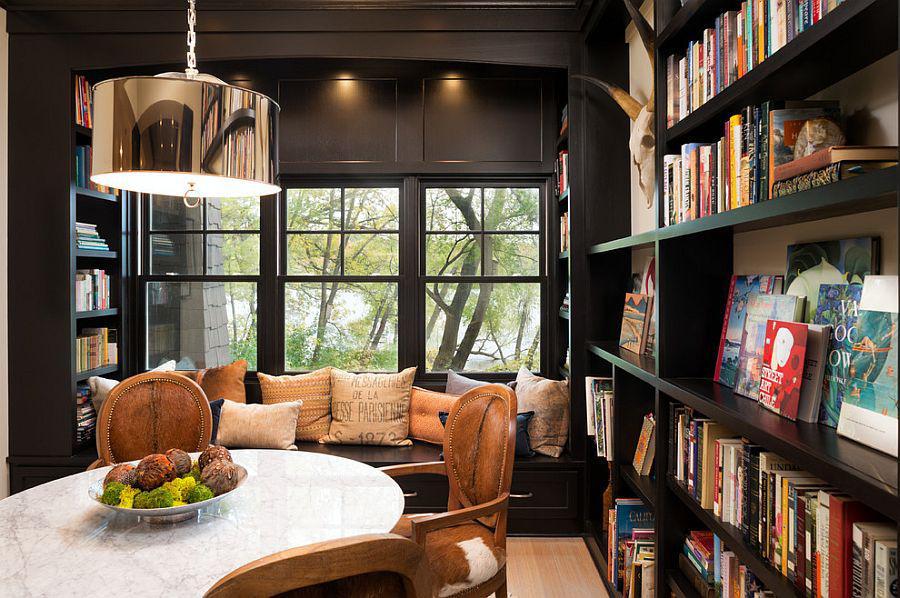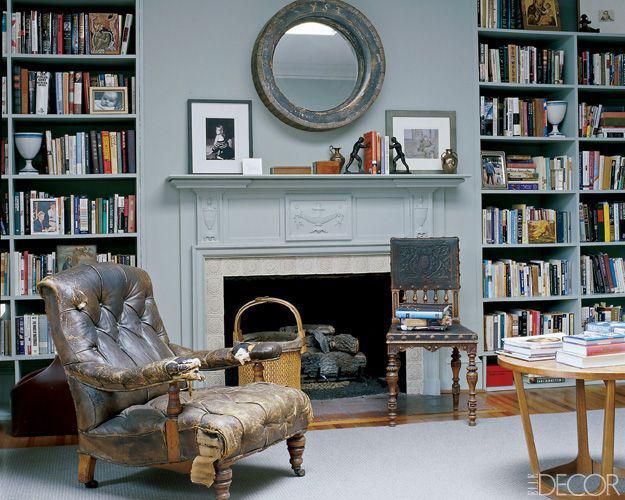The first image is the image on the left, the second image is the image on the right. Evaluate the accuracy of this statement regarding the images: "In one image, floor to ceiling shelving units flank a fire place.". Is it true? Answer yes or no. Yes. The first image is the image on the left, the second image is the image on the right. For the images shown, is this caption "A light fixture is suspended at the center of the room in the right image." true? Answer yes or no. No. 